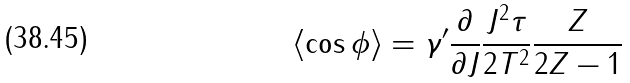<formula> <loc_0><loc_0><loc_500><loc_500>\langle \cos \phi \rangle = \gamma ^ { \prime } \frac { \partial } { \partial J } \frac { J ^ { 2 } \tau } { 2 T ^ { 2 } } \frac { Z } { 2 Z - 1 }</formula> 